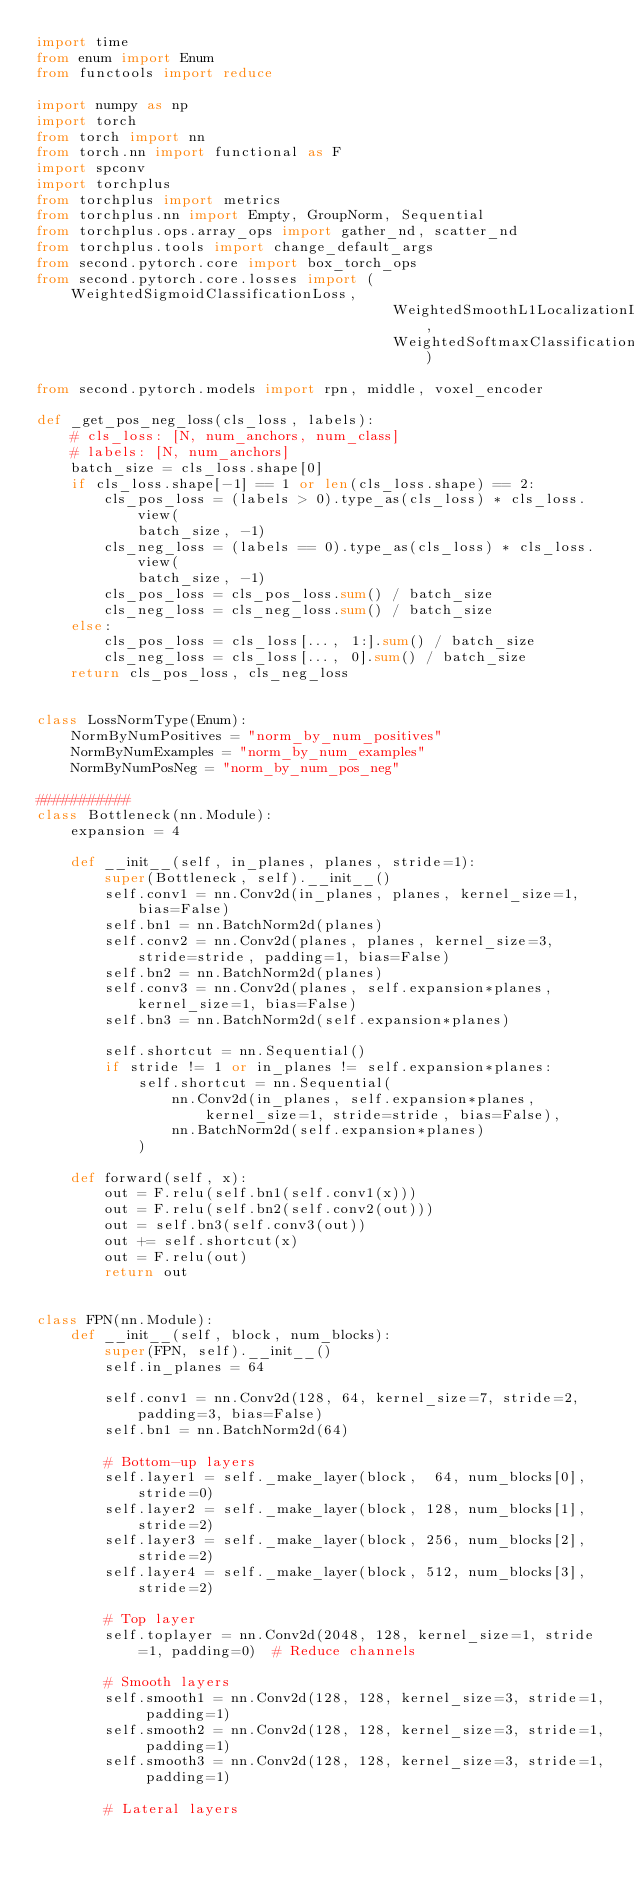Convert code to text. <code><loc_0><loc_0><loc_500><loc_500><_Python_>import time
from enum import Enum
from functools import reduce

import numpy as np
import torch
from torch import nn
from torch.nn import functional as F
import spconv
import torchplus
from torchplus import metrics
from torchplus.nn import Empty, GroupNorm, Sequential
from torchplus.ops.array_ops import gather_nd, scatter_nd
from torchplus.tools import change_default_args
from second.pytorch.core import box_torch_ops
from second.pytorch.core.losses import (WeightedSigmoidClassificationLoss,
                                          WeightedSmoothL1LocalizationLoss,
                                          WeightedSoftmaxClassificationLoss)

from second.pytorch.models import rpn, middle, voxel_encoder

def _get_pos_neg_loss(cls_loss, labels):
    # cls_loss: [N, num_anchors, num_class]
    # labels: [N, num_anchors]
    batch_size = cls_loss.shape[0]
    if cls_loss.shape[-1] == 1 or len(cls_loss.shape) == 2:
        cls_pos_loss = (labels > 0).type_as(cls_loss) * cls_loss.view(
            batch_size, -1)
        cls_neg_loss = (labels == 0).type_as(cls_loss) * cls_loss.view(
            batch_size, -1)
        cls_pos_loss = cls_pos_loss.sum() / batch_size
        cls_neg_loss = cls_neg_loss.sum() / batch_size
    else:
        cls_pos_loss = cls_loss[..., 1:].sum() / batch_size
        cls_neg_loss = cls_loss[..., 0].sum() / batch_size
    return cls_pos_loss, cls_neg_loss


class LossNormType(Enum):
    NormByNumPositives = "norm_by_num_positives"
    NormByNumExamples = "norm_by_num_examples"
    NormByNumPosNeg = "norm_by_num_pos_neg"

###########
class Bottleneck(nn.Module):
    expansion = 4

    def __init__(self, in_planes, planes, stride=1):
        super(Bottleneck, self).__init__()
        self.conv1 = nn.Conv2d(in_planes, planes, kernel_size=1, bias=False)
        self.bn1 = nn.BatchNorm2d(planes)
        self.conv2 = nn.Conv2d(planes, planes, kernel_size=3, stride=stride, padding=1, bias=False)
        self.bn2 = nn.BatchNorm2d(planes)
        self.conv3 = nn.Conv2d(planes, self.expansion*planes, kernel_size=1, bias=False)
        self.bn3 = nn.BatchNorm2d(self.expansion*planes)

        self.shortcut = nn.Sequential()
        if stride != 1 or in_planes != self.expansion*planes:
            self.shortcut = nn.Sequential(
                nn.Conv2d(in_planes, self.expansion*planes, kernel_size=1, stride=stride, bias=False),
                nn.BatchNorm2d(self.expansion*planes)
            )

    def forward(self, x):
        out = F.relu(self.bn1(self.conv1(x)))
        out = F.relu(self.bn2(self.conv2(out)))
        out = self.bn3(self.conv3(out))
        out += self.shortcut(x)
        out = F.relu(out)
        return out


class FPN(nn.Module):
    def __init__(self, block, num_blocks):
        super(FPN, self).__init__()
        self.in_planes = 64

        self.conv1 = nn.Conv2d(128, 64, kernel_size=7, stride=2, padding=3, bias=False)
        self.bn1 = nn.BatchNorm2d(64)

        # Bottom-up layers
        self.layer1 = self._make_layer(block,  64, num_blocks[0], stride=0)
        self.layer2 = self._make_layer(block, 128, num_blocks[1], stride=2)
        self.layer3 = self._make_layer(block, 256, num_blocks[2], stride=2)
        self.layer4 = self._make_layer(block, 512, num_blocks[3], stride=2)

        # Top layer
        self.toplayer = nn.Conv2d(2048, 128, kernel_size=1, stride=1, padding=0)  # Reduce channels

        # Smooth layers
        self.smooth1 = nn.Conv2d(128, 128, kernel_size=3, stride=1, padding=1)
        self.smooth2 = nn.Conv2d(128, 128, kernel_size=3, stride=1, padding=1)
        self.smooth3 = nn.Conv2d(128, 128, kernel_size=3, stride=1, padding=1)

        # Lateral layers</code> 